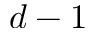Convert formula to latex. <formula><loc_0><loc_0><loc_500><loc_500>d - 1</formula> 